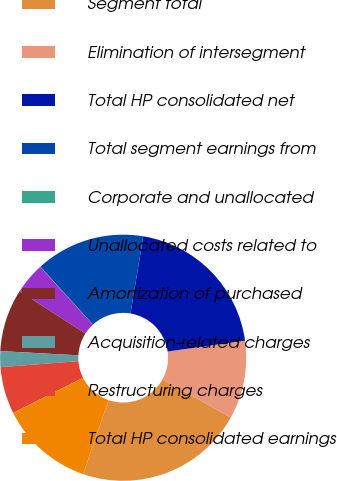<chart> <loc_0><loc_0><loc_500><loc_500><pie_chart><fcel>Segment total<fcel>Elimination of intersegment<fcel>Total HP consolidated net<fcel>Total segment earnings from<fcel>Corporate and unallocated<fcel>Unallocated costs related to<fcel>Amortization of purchased<fcel>Acquisition-related charges<fcel>Restructuring charges<fcel>Total HP consolidated earnings<nl><fcel>22.22%<fcel>10.27%<fcel>20.18%<fcel>14.36%<fcel>0.04%<fcel>4.13%<fcel>8.22%<fcel>2.08%<fcel>6.18%<fcel>12.32%<nl></chart> 